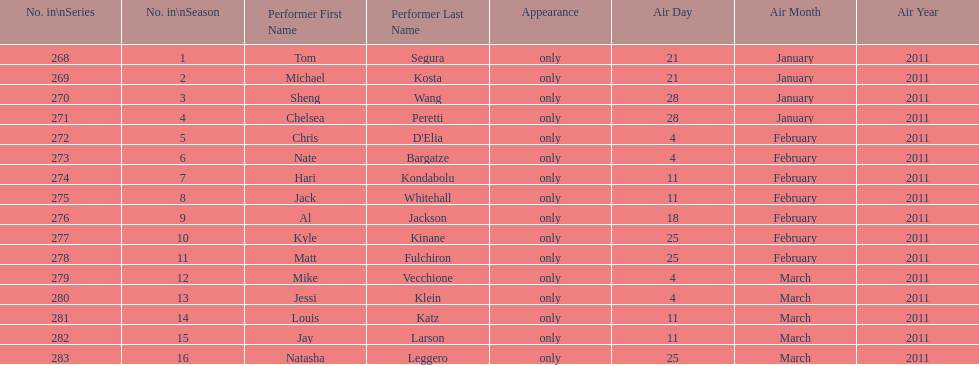What is the name of the last performer on this chart? Natasha Leggero. 